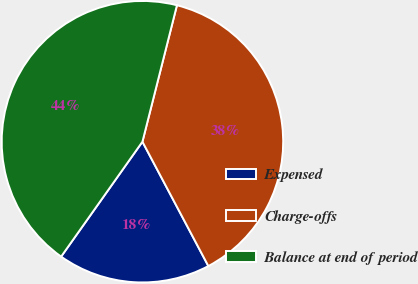Convert chart to OTSL. <chart><loc_0><loc_0><loc_500><loc_500><pie_chart><fcel>Expensed<fcel>Charge-offs<fcel>Balance at end of period<nl><fcel>17.56%<fcel>38.3%<fcel>44.14%<nl></chart> 